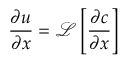<formula> <loc_0><loc_0><loc_500><loc_500>\frac { \partial u } { \partial x } = \mathcal { L } \left [ \frac { \partial c } { \partial x } \right ]</formula> 